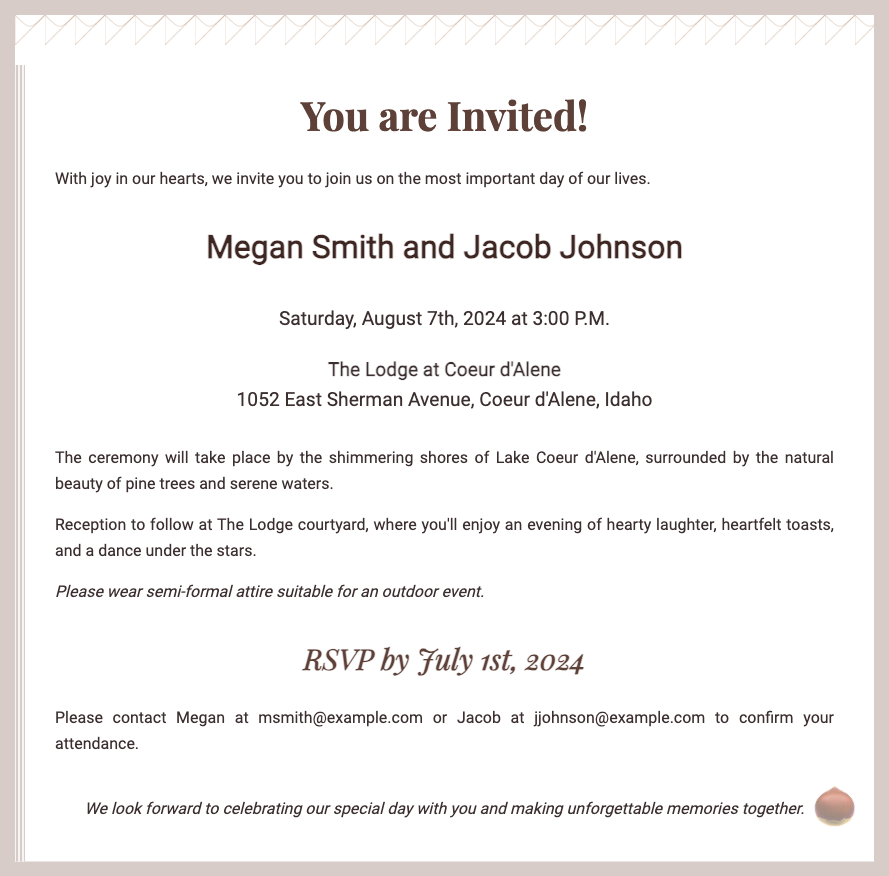What are the names of the couple? The names are prominently featured in the invitation, specifically highlighting those getting married.
Answer: Megan Smith and Jacob Johnson When is the wedding ceremony scheduled? The date and time of the ceremony are clearly stated in the invitation details.
Answer: Saturday, August 7th, 2024 at 3:00 P.M Where will the wedding take place? The location is listed in a dedicated section, indicating where guests should gather for the event.
Answer: The Lodge at Coeur d'Alene What is the RSVP deadline? This important date for guests to respond is mentioned in the RSVP section of the invitation.
Answer: July 1st, 2024 What type of attire should guests wear? The invitation gives specific guidance on appropriate clothing for the occasion.
Answer: Semi-formal attire suitable for an outdoor event What natural elements are mentioned in the ceremony location? The description of the ceremony area includes specific flora and scenery indicative of the venue.
Answer: Pine trees and serene waters What type of celebration follows the ceremony? The invitation describes what guests can expect after the wedding ceremony.
Answer: Reception How should attendees contact the couple to RSVP? Contact information for RSVP is provided, making it easy for guests to confirm their attendance.
Answer: msmith@example.com or jjohnson@example.com 